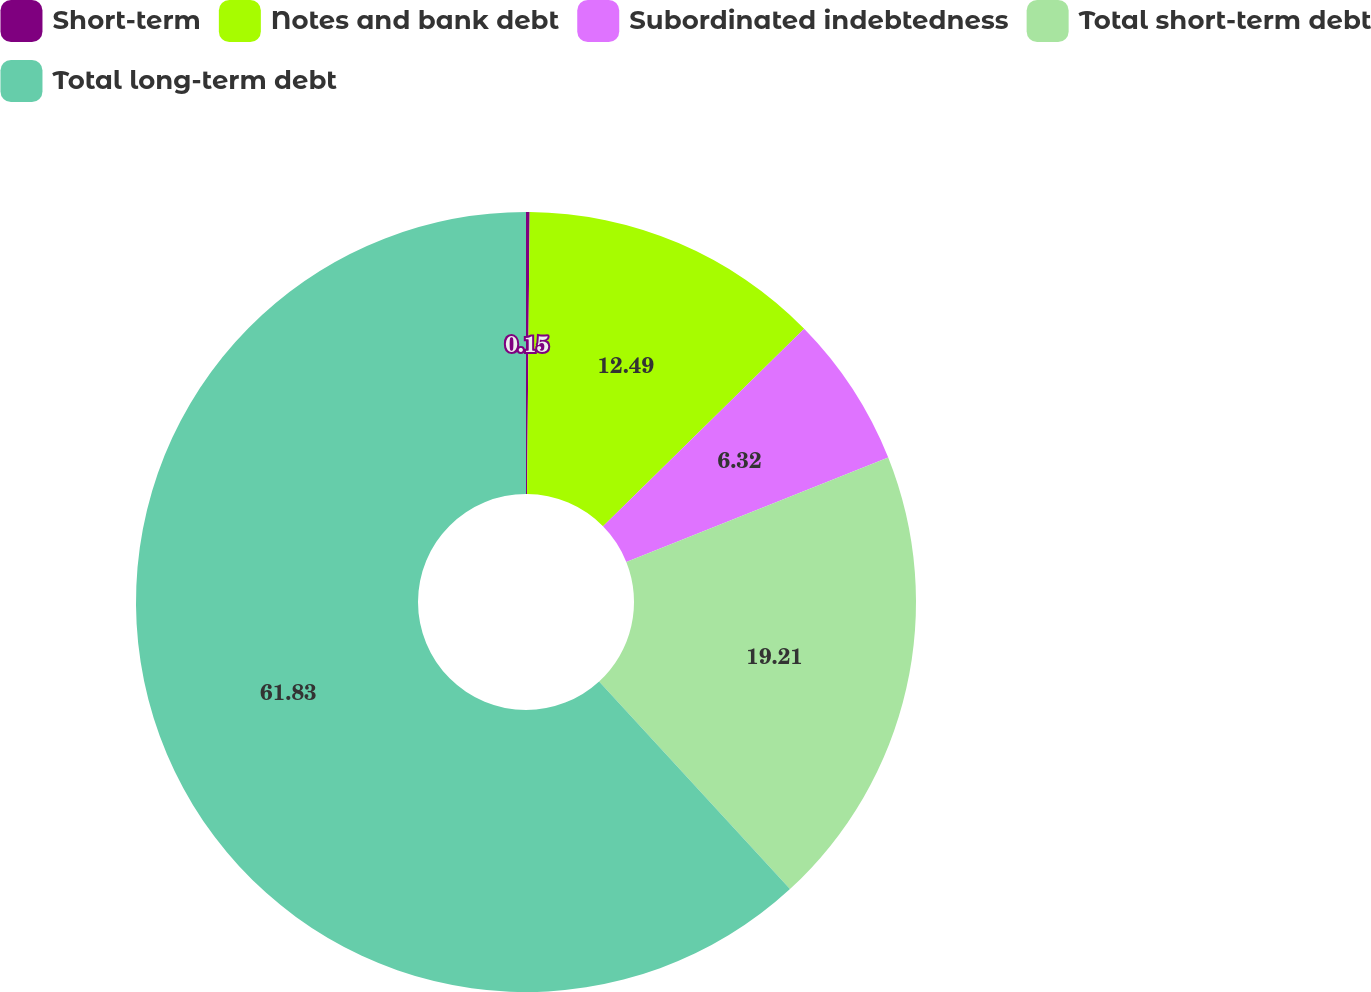<chart> <loc_0><loc_0><loc_500><loc_500><pie_chart><fcel>Short-term<fcel>Notes and bank debt<fcel>Subordinated indebtedness<fcel>Total short-term debt<fcel>Total long-term debt<nl><fcel>0.15%<fcel>12.49%<fcel>6.32%<fcel>19.21%<fcel>61.84%<nl></chart> 